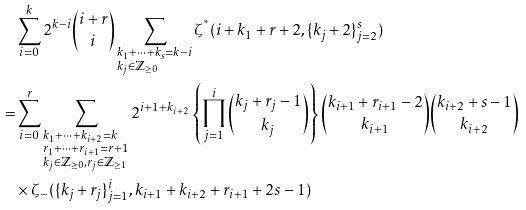Convert formula to latex. <formula><loc_0><loc_0><loc_500><loc_500>& \sum _ { i = 0 } ^ { k } 2 ^ { k - i } \binom { i + r } { i } \sum _ { \begin{subarray} { c } k _ { 1 } + \cdots + k _ { s } = k - i \\ k _ { j } \in \mathbb { Z } _ { \geq 0 } \end{subarray} } \zeta ^ { ^ { * } } ( i + k _ { 1 } + r + 2 , \{ k _ { j } + 2 \} _ { j = 2 } ^ { s } ) \\ = & \sum _ { i = 0 } ^ { r } \sum _ { \begin{subarray} { c } k _ { 1 } + \cdots + k _ { i + 2 } = k \\ r _ { 1 } + \cdots + r _ { i + 1 } = r + 1 \\ k _ { j } \in \mathbb { Z } _ { \geq 0 } , r _ { j } \in \mathbb { Z } _ { \geq 1 } \end{subarray} } 2 ^ { i + 1 + k _ { i + 2 } } \left \{ \prod _ { j = 1 } ^ { i } \binom { k _ { j } + r _ { j } - 1 } { k _ { j } } \right \} \binom { k _ { i + 1 } + r _ { i + 1 } - 2 } { k _ { i + 1 } } \binom { k _ { i + 2 } + s - 1 } { k _ { i + 2 } } \\ & \times \zeta _ { - } ( \{ k _ { j } + r _ { j } \} _ { j = 1 } ^ { i } , k _ { i + 1 } + k _ { i + 2 } + r _ { i + 1 } + 2 s - 1 )</formula> 